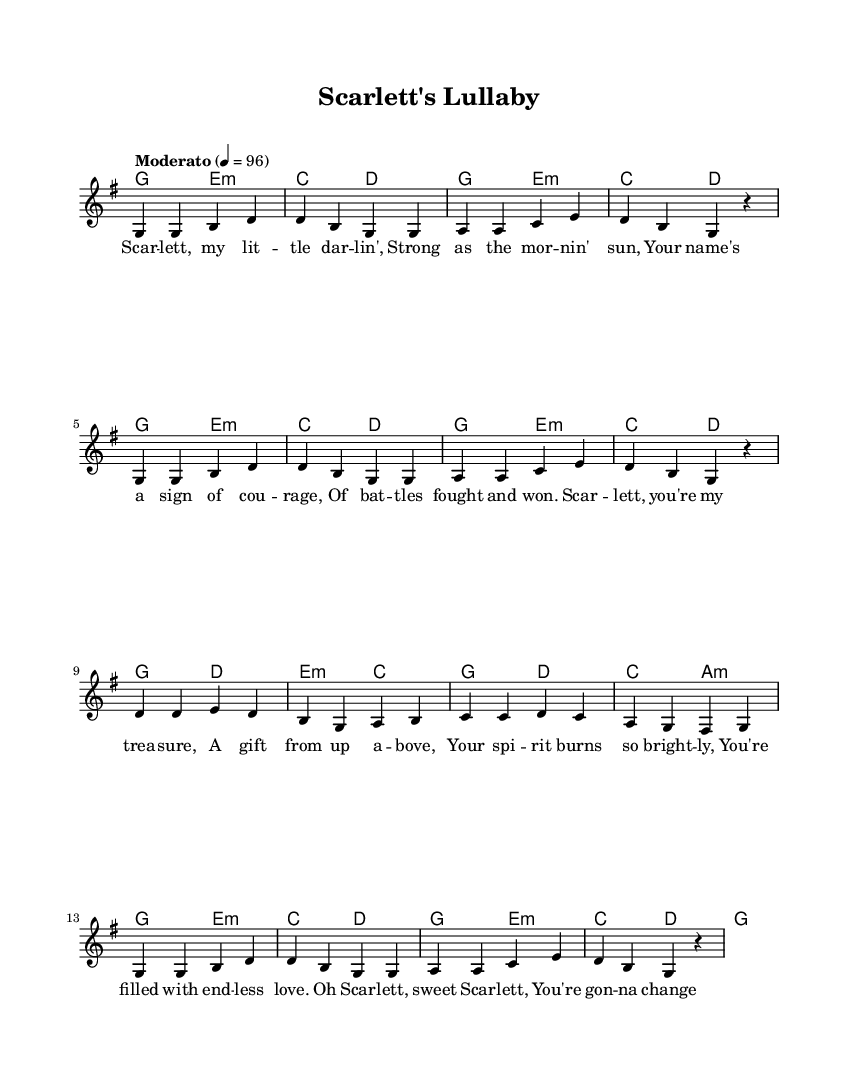What is the key signature of this music? The key signature is G major, which has one sharp, F#. This can be identified by looking at the key signature indicated on the staff at the beginning of the piece.
Answer: G major What is the time signature of this music? The time signature is 4/4, meaning there are 4 beats in each measure and the quarter note gets one beat. This can be seen written at the beginning of the score.
Answer: 4/4 What is the tempo marking for this piece? The tempo marking is "Moderato," which indicates a moderate pace. This is specified at the start of the score, along with the metronome marking of 96 beats per minute.
Answer: Moderato How many measures are in the melody section? There are 16 measures in the melody section, which can be counted by looking at the notation and identifying where each measure ends.
Answer: 16 What is the structure of the lyrics in the first verse? The structure of the lyrics follows a four-line verse that is repeated, typical in country music. This can be noted by the lyrical layout under the melody, with consistent phrasing.
Answer: Four-line verse What type of harmony is primarily used in this piece? The harmony primarily consists of major and minor chords, typical of country music's tonal structure. This can be analyzed by reviewing the chord symbols written throughout the piece.
Answer: Major and minor chords What is the title of this piece? The title of the piece is "Scarlett's Lullaby," which is indicated at the top of the sheet music under the header section.
Answer: Scarlett's Lullaby 